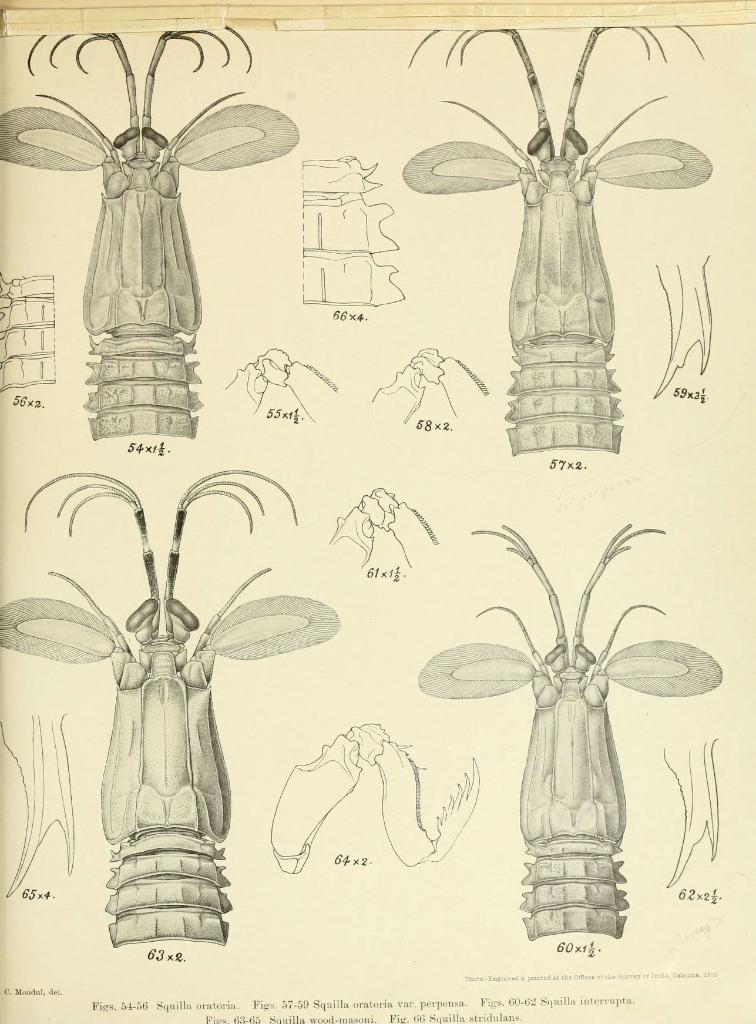Please provide a concise description of this image. In this image we can see a sketch of the insects and parts of the insects. 